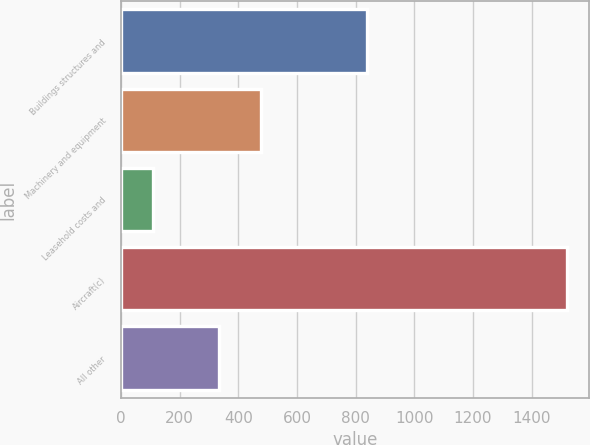Convert chart to OTSL. <chart><loc_0><loc_0><loc_500><loc_500><bar_chart><fcel>Buildings structures and<fcel>Machinery and equipment<fcel>Leasehold costs and<fcel>Aircraft(c)<fcel>All other<nl><fcel>840<fcel>476<fcel>110<fcel>1520<fcel>335<nl></chart> 